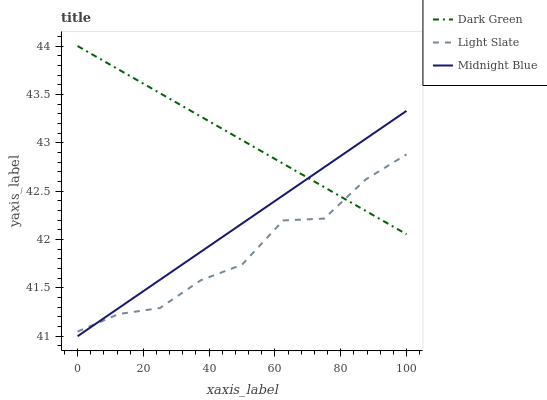Does Light Slate have the minimum area under the curve?
Answer yes or no. Yes. Does Dark Green have the maximum area under the curve?
Answer yes or no. Yes. Does Midnight Blue have the minimum area under the curve?
Answer yes or no. No. Does Midnight Blue have the maximum area under the curve?
Answer yes or no. No. Is Midnight Blue the smoothest?
Answer yes or no. Yes. Is Light Slate the roughest?
Answer yes or no. Yes. Is Dark Green the smoothest?
Answer yes or no. No. Is Dark Green the roughest?
Answer yes or no. No. Does Dark Green have the lowest value?
Answer yes or no. No. Does Dark Green have the highest value?
Answer yes or no. Yes. Does Midnight Blue have the highest value?
Answer yes or no. No. Does Light Slate intersect Dark Green?
Answer yes or no. Yes. Is Light Slate less than Dark Green?
Answer yes or no. No. Is Light Slate greater than Dark Green?
Answer yes or no. No. 